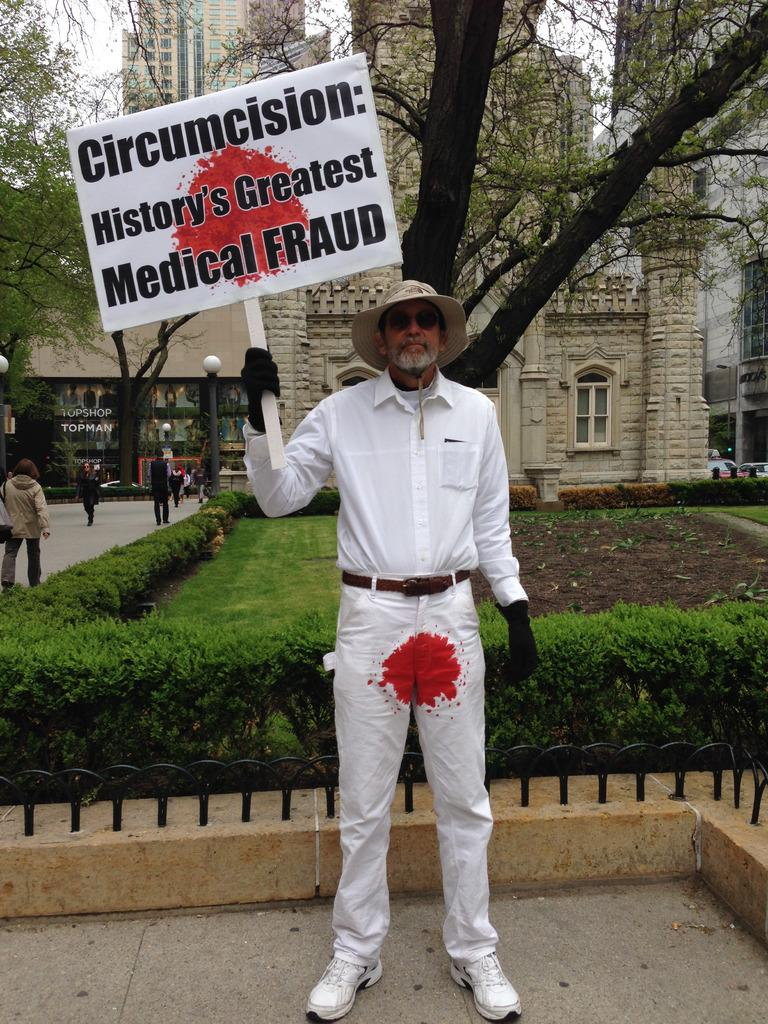What type of vegetation can be seen in the image? There are plants and grass in the image. Are there any human subjects in the image? Yes, there are people in the image. What type of structures are visible in the image? There are buildings in the image. What is visible in the sky in the image? The sky is visible in the image, and there are clouds present. What additional object can be seen in the image? There is a banner in the image. Can you describe the person in the front of the image? There is a person wearing a white dress in the front of the image. What type of dirt can be seen on the person wearing the white dress in the image? There is no dirt visible on the person wearing the white dress in the image. What type of body is present in the image? The image contains human bodies, as there are people present. However, there is no specific body being referred to in the image. 